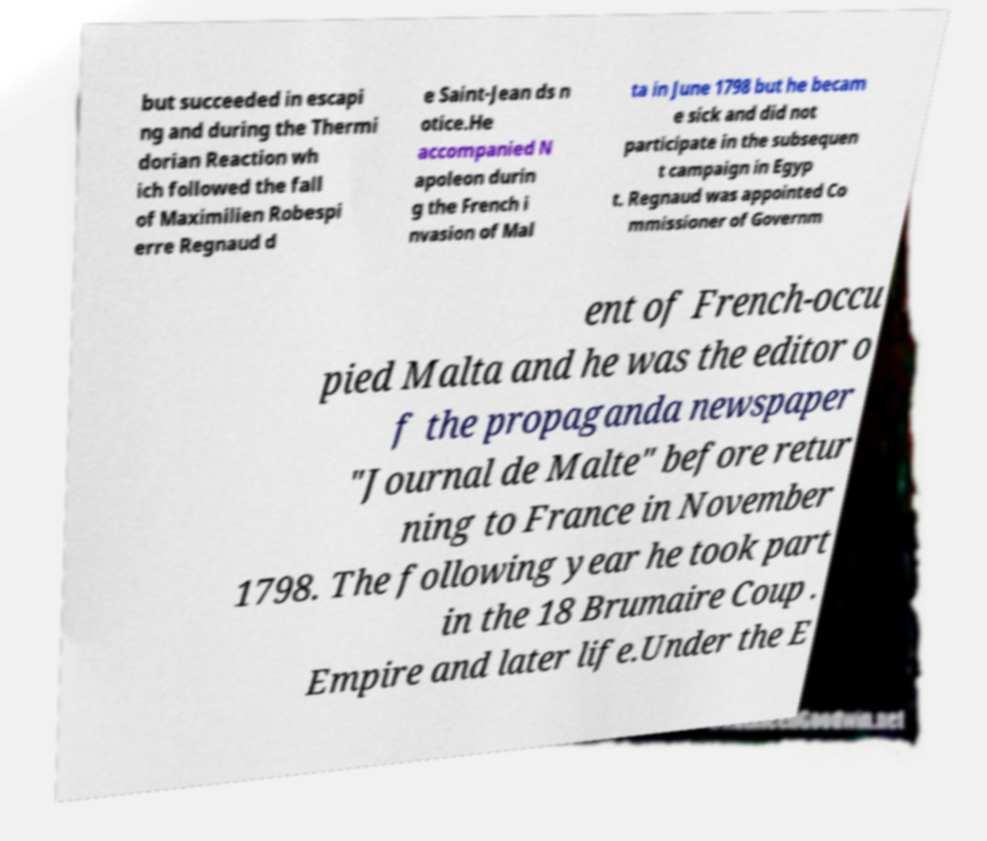There's text embedded in this image that I need extracted. Can you transcribe it verbatim? but succeeded in escapi ng and during the Thermi dorian Reaction wh ich followed the fall of Maximilien Robespi erre Regnaud d e Saint-Jean ds n otice.He accompanied N apoleon durin g the French i nvasion of Mal ta in June 1798 but he becam e sick and did not participate in the subsequen t campaign in Egyp t. Regnaud was appointed Co mmissioner of Governm ent of French-occu pied Malta and he was the editor o f the propaganda newspaper "Journal de Malte" before retur ning to France in November 1798. The following year he took part in the 18 Brumaire Coup . Empire and later life.Under the E 